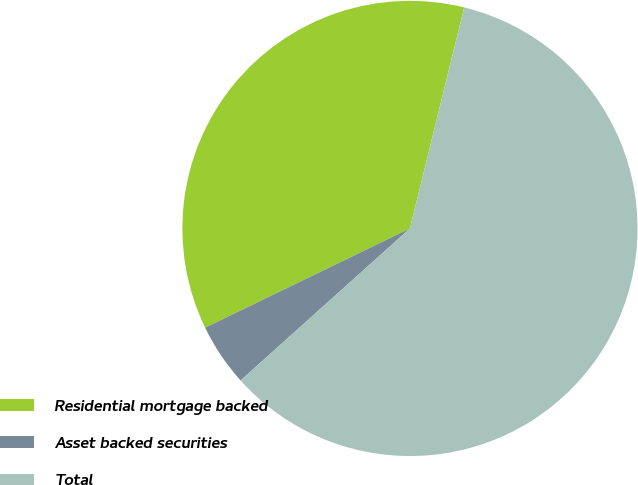<chart> <loc_0><loc_0><loc_500><loc_500><pie_chart><fcel>Residential mortgage backed<fcel>Asset backed securities<fcel>Total<nl><fcel>36.01%<fcel>4.46%<fcel>59.53%<nl></chart> 